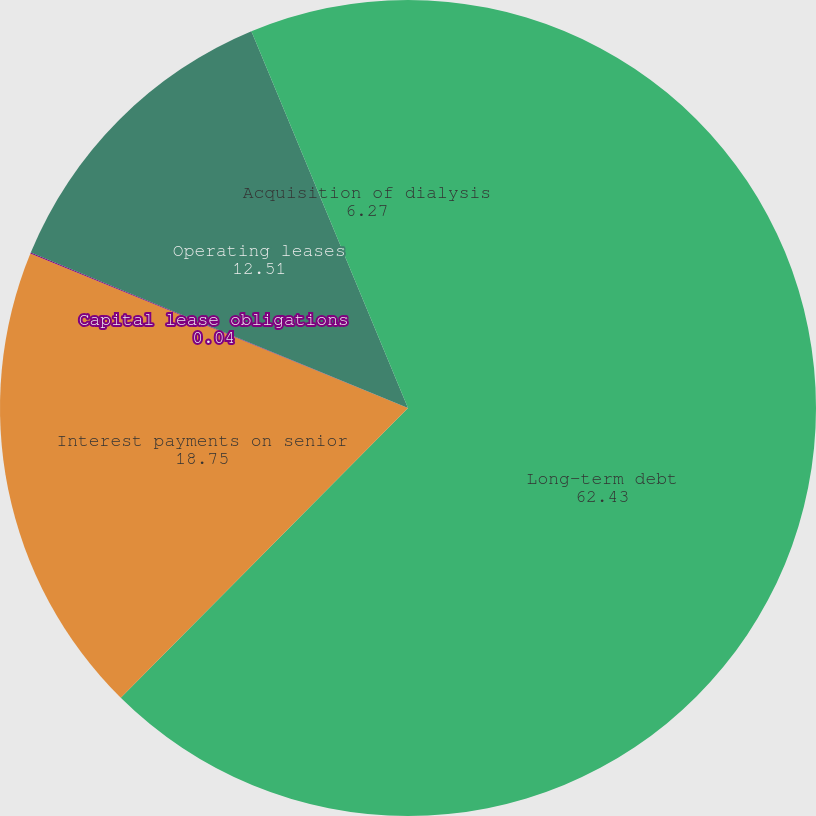<chart> <loc_0><loc_0><loc_500><loc_500><pie_chart><fcel>Long-term debt<fcel>Interest payments on senior<fcel>Capital lease obligations<fcel>Operating leases<fcel>Acquisition of dialysis<nl><fcel>62.43%<fcel>18.75%<fcel>0.04%<fcel>12.51%<fcel>6.27%<nl></chart> 